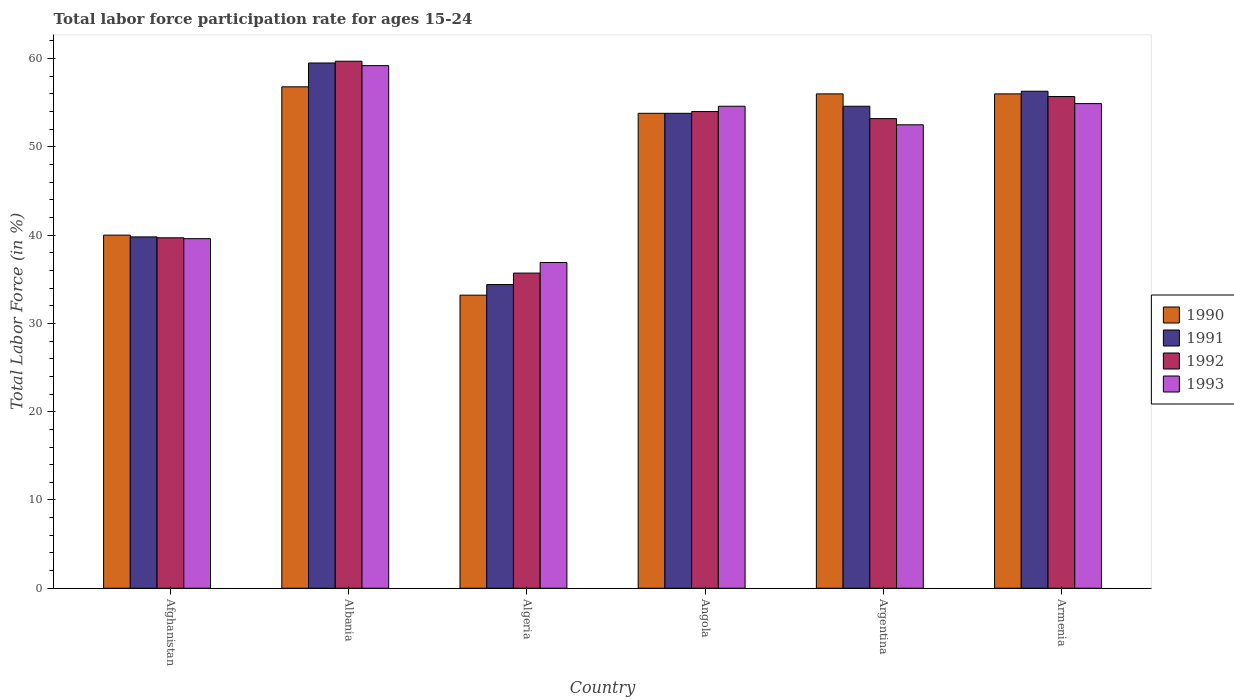How many different coloured bars are there?
Your answer should be very brief. 4. How many bars are there on the 6th tick from the right?
Provide a succinct answer. 4. In how many cases, is the number of bars for a given country not equal to the number of legend labels?
Your answer should be very brief. 0. Across all countries, what is the maximum labor force participation rate in 1990?
Ensure brevity in your answer.  56.8. Across all countries, what is the minimum labor force participation rate in 1991?
Make the answer very short. 34.4. In which country was the labor force participation rate in 1992 maximum?
Make the answer very short. Albania. In which country was the labor force participation rate in 1993 minimum?
Your answer should be compact. Algeria. What is the total labor force participation rate in 1992 in the graph?
Your answer should be very brief. 298. What is the difference between the labor force participation rate in 1993 in Albania and that in Angola?
Your answer should be compact. 4.6. What is the difference between the labor force participation rate in 1990 in Armenia and the labor force participation rate in 1993 in Angola?
Give a very brief answer. 1.4. What is the average labor force participation rate in 1990 per country?
Provide a succinct answer. 49.3. What is the difference between the labor force participation rate of/in 1991 and labor force participation rate of/in 1993 in Angola?
Offer a very short reply. -0.8. What is the ratio of the labor force participation rate in 1990 in Albania to that in Algeria?
Make the answer very short. 1.71. Is the labor force participation rate in 1992 in Afghanistan less than that in Armenia?
Your response must be concise. Yes. Is the difference between the labor force participation rate in 1991 in Albania and Angola greater than the difference between the labor force participation rate in 1993 in Albania and Angola?
Your answer should be very brief. Yes. What is the difference between the highest and the second highest labor force participation rate in 1993?
Offer a terse response. -4.6. What is the difference between the highest and the lowest labor force participation rate in 1990?
Your response must be concise. 23.6. Is it the case that in every country, the sum of the labor force participation rate in 1993 and labor force participation rate in 1990 is greater than the sum of labor force participation rate in 1992 and labor force participation rate in 1991?
Make the answer very short. No. What does the 3rd bar from the right in Albania represents?
Offer a very short reply. 1991. Are the values on the major ticks of Y-axis written in scientific E-notation?
Offer a very short reply. No. Does the graph contain grids?
Keep it short and to the point. No. Where does the legend appear in the graph?
Keep it short and to the point. Center right. How many legend labels are there?
Provide a short and direct response. 4. What is the title of the graph?
Your response must be concise. Total labor force participation rate for ages 15-24. What is the Total Labor Force (in %) of 1990 in Afghanistan?
Your response must be concise. 40. What is the Total Labor Force (in %) of 1991 in Afghanistan?
Your answer should be compact. 39.8. What is the Total Labor Force (in %) in 1992 in Afghanistan?
Keep it short and to the point. 39.7. What is the Total Labor Force (in %) of 1993 in Afghanistan?
Provide a succinct answer. 39.6. What is the Total Labor Force (in %) of 1990 in Albania?
Your answer should be very brief. 56.8. What is the Total Labor Force (in %) in 1991 in Albania?
Offer a terse response. 59.5. What is the Total Labor Force (in %) of 1992 in Albania?
Your answer should be very brief. 59.7. What is the Total Labor Force (in %) of 1993 in Albania?
Keep it short and to the point. 59.2. What is the Total Labor Force (in %) of 1990 in Algeria?
Keep it short and to the point. 33.2. What is the Total Labor Force (in %) in 1991 in Algeria?
Offer a very short reply. 34.4. What is the Total Labor Force (in %) of 1992 in Algeria?
Keep it short and to the point. 35.7. What is the Total Labor Force (in %) in 1993 in Algeria?
Keep it short and to the point. 36.9. What is the Total Labor Force (in %) of 1990 in Angola?
Offer a very short reply. 53.8. What is the Total Labor Force (in %) in 1991 in Angola?
Provide a succinct answer. 53.8. What is the Total Labor Force (in %) of 1993 in Angola?
Make the answer very short. 54.6. What is the Total Labor Force (in %) in 1990 in Argentina?
Make the answer very short. 56. What is the Total Labor Force (in %) of 1991 in Argentina?
Your response must be concise. 54.6. What is the Total Labor Force (in %) in 1992 in Argentina?
Offer a terse response. 53.2. What is the Total Labor Force (in %) in 1993 in Argentina?
Provide a short and direct response. 52.5. What is the Total Labor Force (in %) in 1991 in Armenia?
Provide a succinct answer. 56.3. What is the Total Labor Force (in %) of 1992 in Armenia?
Make the answer very short. 55.7. What is the Total Labor Force (in %) of 1993 in Armenia?
Your answer should be very brief. 54.9. Across all countries, what is the maximum Total Labor Force (in %) in 1990?
Your answer should be compact. 56.8. Across all countries, what is the maximum Total Labor Force (in %) in 1991?
Your response must be concise. 59.5. Across all countries, what is the maximum Total Labor Force (in %) of 1992?
Your response must be concise. 59.7. Across all countries, what is the maximum Total Labor Force (in %) in 1993?
Your answer should be compact. 59.2. Across all countries, what is the minimum Total Labor Force (in %) in 1990?
Offer a terse response. 33.2. Across all countries, what is the minimum Total Labor Force (in %) of 1991?
Provide a succinct answer. 34.4. Across all countries, what is the minimum Total Labor Force (in %) in 1992?
Your answer should be compact. 35.7. Across all countries, what is the minimum Total Labor Force (in %) of 1993?
Keep it short and to the point. 36.9. What is the total Total Labor Force (in %) in 1990 in the graph?
Your response must be concise. 295.8. What is the total Total Labor Force (in %) in 1991 in the graph?
Your answer should be compact. 298.4. What is the total Total Labor Force (in %) of 1992 in the graph?
Give a very brief answer. 298. What is the total Total Labor Force (in %) in 1993 in the graph?
Your response must be concise. 297.7. What is the difference between the Total Labor Force (in %) in 1990 in Afghanistan and that in Albania?
Keep it short and to the point. -16.8. What is the difference between the Total Labor Force (in %) in 1991 in Afghanistan and that in Albania?
Your response must be concise. -19.7. What is the difference between the Total Labor Force (in %) in 1993 in Afghanistan and that in Albania?
Your response must be concise. -19.6. What is the difference between the Total Labor Force (in %) in 1990 in Afghanistan and that in Algeria?
Provide a short and direct response. 6.8. What is the difference between the Total Labor Force (in %) in 1991 in Afghanistan and that in Algeria?
Give a very brief answer. 5.4. What is the difference between the Total Labor Force (in %) in 1992 in Afghanistan and that in Algeria?
Give a very brief answer. 4. What is the difference between the Total Labor Force (in %) in 1993 in Afghanistan and that in Algeria?
Keep it short and to the point. 2.7. What is the difference between the Total Labor Force (in %) in 1990 in Afghanistan and that in Angola?
Make the answer very short. -13.8. What is the difference between the Total Labor Force (in %) in 1992 in Afghanistan and that in Angola?
Offer a very short reply. -14.3. What is the difference between the Total Labor Force (in %) in 1993 in Afghanistan and that in Angola?
Your answer should be compact. -15. What is the difference between the Total Labor Force (in %) in 1991 in Afghanistan and that in Argentina?
Offer a very short reply. -14.8. What is the difference between the Total Labor Force (in %) of 1993 in Afghanistan and that in Argentina?
Your response must be concise. -12.9. What is the difference between the Total Labor Force (in %) in 1990 in Afghanistan and that in Armenia?
Your answer should be compact. -16. What is the difference between the Total Labor Force (in %) of 1991 in Afghanistan and that in Armenia?
Your answer should be very brief. -16.5. What is the difference between the Total Labor Force (in %) of 1993 in Afghanistan and that in Armenia?
Ensure brevity in your answer.  -15.3. What is the difference between the Total Labor Force (in %) of 1990 in Albania and that in Algeria?
Give a very brief answer. 23.6. What is the difference between the Total Labor Force (in %) in 1991 in Albania and that in Algeria?
Your answer should be very brief. 25.1. What is the difference between the Total Labor Force (in %) in 1992 in Albania and that in Algeria?
Give a very brief answer. 24. What is the difference between the Total Labor Force (in %) in 1993 in Albania and that in Algeria?
Keep it short and to the point. 22.3. What is the difference between the Total Labor Force (in %) in 1990 in Albania and that in Angola?
Ensure brevity in your answer.  3. What is the difference between the Total Labor Force (in %) in 1993 in Albania and that in Angola?
Your answer should be compact. 4.6. What is the difference between the Total Labor Force (in %) of 1991 in Albania and that in Argentina?
Your answer should be compact. 4.9. What is the difference between the Total Labor Force (in %) of 1992 in Albania and that in Argentina?
Offer a very short reply. 6.5. What is the difference between the Total Labor Force (in %) of 1993 in Albania and that in Armenia?
Make the answer very short. 4.3. What is the difference between the Total Labor Force (in %) of 1990 in Algeria and that in Angola?
Give a very brief answer. -20.6. What is the difference between the Total Labor Force (in %) in 1991 in Algeria and that in Angola?
Offer a very short reply. -19.4. What is the difference between the Total Labor Force (in %) of 1992 in Algeria and that in Angola?
Ensure brevity in your answer.  -18.3. What is the difference between the Total Labor Force (in %) of 1993 in Algeria and that in Angola?
Give a very brief answer. -17.7. What is the difference between the Total Labor Force (in %) of 1990 in Algeria and that in Argentina?
Offer a very short reply. -22.8. What is the difference between the Total Labor Force (in %) of 1991 in Algeria and that in Argentina?
Your answer should be very brief. -20.2. What is the difference between the Total Labor Force (in %) of 1992 in Algeria and that in Argentina?
Ensure brevity in your answer.  -17.5. What is the difference between the Total Labor Force (in %) of 1993 in Algeria and that in Argentina?
Ensure brevity in your answer.  -15.6. What is the difference between the Total Labor Force (in %) of 1990 in Algeria and that in Armenia?
Make the answer very short. -22.8. What is the difference between the Total Labor Force (in %) in 1991 in Algeria and that in Armenia?
Offer a terse response. -21.9. What is the difference between the Total Labor Force (in %) of 1992 in Algeria and that in Armenia?
Your response must be concise. -20. What is the difference between the Total Labor Force (in %) of 1992 in Angola and that in Argentina?
Your answer should be very brief. 0.8. What is the difference between the Total Labor Force (in %) of 1991 in Angola and that in Armenia?
Ensure brevity in your answer.  -2.5. What is the difference between the Total Labor Force (in %) in 1992 in Angola and that in Armenia?
Your answer should be very brief. -1.7. What is the difference between the Total Labor Force (in %) of 1990 in Argentina and that in Armenia?
Provide a short and direct response. 0. What is the difference between the Total Labor Force (in %) of 1992 in Argentina and that in Armenia?
Give a very brief answer. -2.5. What is the difference between the Total Labor Force (in %) in 1990 in Afghanistan and the Total Labor Force (in %) in 1991 in Albania?
Your answer should be compact. -19.5. What is the difference between the Total Labor Force (in %) in 1990 in Afghanistan and the Total Labor Force (in %) in 1992 in Albania?
Your response must be concise. -19.7. What is the difference between the Total Labor Force (in %) of 1990 in Afghanistan and the Total Labor Force (in %) of 1993 in Albania?
Ensure brevity in your answer.  -19.2. What is the difference between the Total Labor Force (in %) in 1991 in Afghanistan and the Total Labor Force (in %) in 1992 in Albania?
Provide a succinct answer. -19.9. What is the difference between the Total Labor Force (in %) in 1991 in Afghanistan and the Total Labor Force (in %) in 1993 in Albania?
Offer a terse response. -19.4. What is the difference between the Total Labor Force (in %) in 1992 in Afghanistan and the Total Labor Force (in %) in 1993 in Albania?
Ensure brevity in your answer.  -19.5. What is the difference between the Total Labor Force (in %) in 1990 in Afghanistan and the Total Labor Force (in %) in 1991 in Algeria?
Keep it short and to the point. 5.6. What is the difference between the Total Labor Force (in %) of 1990 in Afghanistan and the Total Labor Force (in %) of 1992 in Algeria?
Provide a short and direct response. 4.3. What is the difference between the Total Labor Force (in %) of 1990 in Afghanistan and the Total Labor Force (in %) of 1993 in Algeria?
Provide a short and direct response. 3.1. What is the difference between the Total Labor Force (in %) in 1991 in Afghanistan and the Total Labor Force (in %) in 1993 in Algeria?
Your response must be concise. 2.9. What is the difference between the Total Labor Force (in %) of 1990 in Afghanistan and the Total Labor Force (in %) of 1991 in Angola?
Your response must be concise. -13.8. What is the difference between the Total Labor Force (in %) of 1990 in Afghanistan and the Total Labor Force (in %) of 1992 in Angola?
Your response must be concise. -14. What is the difference between the Total Labor Force (in %) of 1990 in Afghanistan and the Total Labor Force (in %) of 1993 in Angola?
Make the answer very short. -14.6. What is the difference between the Total Labor Force (in %) of 1991 in Afghanistan and the Total Labor Force (in %) of 1993 in Angola?
Your answer should be very brief. -14.8. What is the difference between the Total Labor Force (in %) in 1992 in Afghanistan and the Total Labor Force (in %) in 1993 in Angola?
Offer a terse response. -14.9. What is the difference between the Total Labor Force (in %) in 1990 in Afghanistan and the Total Labor Force (in %) in 1991 in Argentina?
Keep it short and to the point. -14.6. What is the difference between the Total Labor Force (in %) in 1990 in Afghanistan and the Total Labor Force (in %) in 1992 in Argentina?
Your answer should be very brief. -13.2. What is the difference between the Total Labor Force (in %) in 1990 in Afghanistan and the Total Labor Force (in %) in 1993 in Argentina?
Ensure brevity in your answer.  -12.5. What is the difference between the Total Labor Force (in %) of 1991 in Afghanistan and the Total Labor Force (in %) of 1992 in Argentina?
Keep it short and to the point. -13.4. What is the difference between the Total Labor Force (in %) in 1992 in Afghanistan and the Total Labor Force (in %) in 1993 in Argentina?
Offer a terse response. -12.8. What is the difference between the Total Labor Force (in %) in 1990 in Afghanistan and the Total Labor Force (in %) in 1991 in Armenia?
Provide a succinct answer. -16.3. What is the difference between the Total Labor Force (in %) of 1990 in Afghanistan and the Total Labor Force (in %) of 1992 in Armenia?
Provide a succinct answer. -15.7. What is the difference between the Total Labor Force (in %) of 1990 in Afghanistan and the Total Labor Force (in %) of 1993 in Armenia?
Provide a succinct answer. -14.9. What is the difference between the Total Labor Force (in %) of 1991 in Afghanistan and the Total Labor Force (in %) of 1992 in Armenia?
Your answer should be compact. -15.9. What is the difference between the Total Labor Force (in %) of 1991 in Afghanistan and the Total Labor Force (in %) of 1993 in Armenia?
Make the answer very short. -15.1. What is the difference between the Total Labor Force (in %) in 1992 in Afghanistan and the Total Labor Force (in %) in 1993 in Armenia?
Provide a succinct answer. -15.2. What is the difference between the Total Labor Force (in %) of 1990 in Albania and the Total Labor Force (in %) of 1991 in Algeria?
Keep it short and to the point. 22.4. What is the difference between the Total Labor Force (in %) of 1990 in Albania and the Total Labor Force (in %) of 1992 in Algeria?
Your response must be concise. 21.1. What is the difference between the Total Labor Force (in %) in 1990 in Albania and the Total Labor Force (in %) in 1993 in Algeria?
Offer a terse response. 19.9. What is the difference between the Total Labor Force (in %) of 1991 in Albania and the Total Labor Force (in %) of 1992 in Algeria?
Offer a terse response. 23.8. What is the difference between the Total Labor Force (in %) in 1991 in Albania and the Total Labor Force (in %) in 1993 in Algeria?
Provide a succinct answer. 22.6. What is the difference between the Total Labor Force (in %) of 1992 in Albania and the Total Labor Force (in %) of 1993 in Algeria?
Your response must be concise. 22.8. What is the difference between the Total Labor Force (in %) in 1990 in Albania and the Total Labor Force (in %) in 1991 in Angola?
Keep it short and to the point. 3. What is the difference between the Total Labor Force (in %) in 1990 in Albania and the Total Labor Force (in %) in 1992 in Angola?
Make the answer very short. 2.8. What is the difference between the Total Labor Force (in %) of 1991 in Albania and the Total Labor Force (in %) of 1992 in Angola?
Your response must be concise. 5.5. What is the difference between the Total Labor Force (in %) in 1992 in Albania and the Total Labor Force (in %) in 1993 in Angola?
Keep it short and to the point. 5.1. What is the difference between the Total Labor Force (in %) in 1990 in Albania and the Total Labor Force (in %) in 1992 in Argentina?
Give a very brief answer. 3.6. What is the difference between the Total Labor Force (in %) in 1990 in Albania and the Total Labor Force (in %) in 1993 in Argentina?
Ensure brevity in your answer.  4.3. What is the difference between the Total Labor Force (in %) of 1991 in Albania and the Total Labor Force (in %) of 1993 in Argentina?
Provide a short and direct response. 7. What is the difference between the Total Labor Force (in %) in 1990 in Albania and the Total Labor Force (in %) in 1991 in Armenia?
Ensure brevity in your answer.  0.5. What is the difference between the Total Labor Force (in %) of 1991 in Albania and the Total Labor Force (in %) of 1993 in Armenia?
Provide a short and direct response. 4.6. What is the difference between the Total Labor Force (in %) of 1990 in Algeria and the Total Labor Force (in %) of 1991 in Angola?
Ensure brevity in your answer.  -20.6. What is the difference between the Total Labor Force (in %) in 1990 in Algeria and the Total Labor Force (in %) in 1992 in Angola?
Your answer should be compact. -20.8. What is the difference between the Total Labor Force (in %) in 1990 in Algeria and the Total Labor Force (in %) in 1993 in Angola?
Ensure brevity in your answer.  -21.4. What is the difference between the Total Labor Force (in %) of 1991 in Algeria and the Total Labor Force (in %) of 1992 in Angola?
Offer a very short reply. -19.6. What is the difference between the Total Labor Force (in %) in 1991 in Algeria and the Total Labor Force (in %) in 1993 in Angola?
Give a very brief answer. -20.2. What is the difference between the Total Labor Force (in %) in 1992 in Algeria and the Total Labor Force (in %) in 1993 in Angola?
Ensure brevity in your answer.  -18.9. What is the difference between the Total Labor Force (in %) of 1990 in Algeria and the Total Labor Force (in %) of 1991 in Argentina?
Provide a short and direct response. -21.4. What is the difference between the Total Labor Force (in %) of 1990 in Algeria and the Total Labor Force (in %) of 1993 in Argentina?
Give a very brief answer. -19.3. What is the difference between the Total Labor Force (in %) of 1991 in Algeria and the Total Labor Force (in %) of 1992 in Argentina?
Provide a succinct answer. -18.8. What is the difference between the Total Labor Force (in %) of 1991 in Algeria and the Total Labor Force (in %) of 1993 in Argentina?
Ensure brevity in your answer.  -18.1. What is the difference between the Total Labor Force (in %) of 1992 in Algeria and the Total Labor Force (in %) of 1993 in Argentina?
Offer a very short reply. -16.8. What is the difference between the Total Labor Force (in %) of 1990 in Algeria and the Total Labor Force (in %) of 1991 in Armenia?
Give a very brief answer. -23.1. What is the difference between the Total Labor Force (in %) in 1990 in Algeria and the Total Labor Force (in %) in 1992 in Armenia?
Keep it short and to the point. -22.5. What is the difference between the Total Labor Force (in %) in 1990 in Algeria and the Total Labor Force (in %) in 1993 in Armenia?
Give a very brief answer. -21.7. What is the difference between the Total Labor Force (in %) in 1991 in Algeria and the Total Labor Force (in %) in 1992 in Armenia?
Provide a succinct answer. -21.3. What is the difference between the Total Labor Force (in %) of 1991 in Algeria and the Total Labor Force (in %) of 1993 in Armenia?
Provide a short and direct response. -20.5. What is the difference between the Total Labor Force (in %) in 1992 in Algeria and the Total Labor Force (in %) in 1993 in Armenia?
Provide a short and direct response. -19.2. What is the difference between the Total Labor Force (in %) in 1990 in Angola and the Total Labor Force (in %) in 1992 in Argentina?
Keep it short and to the point. 0.6. What is the difference between the Total Labor Force (in %) of 1991 in Angola and the Total Labor Force (in %) of 1992 in Argentina?
Your response must be concise. 0.6. What is the difference between the Total Labor Force (in %) in 1992 in Angola and the Total Labor Force (in %) in 1993 in Argentina?
Provide a succinct answer. 1.5. What is the difference between the Total Labor Force (in %) of 1990 in Angola and the Total Labor Force (in %) of 1991 in Armenia?
Offer a very short reply. -2.5. What is the difference between the Total Labor Force (in %) in 1991 in Angola and the Total Labor Force (in %) in 1992 in Armenia?
Give a very brief answer. -1.9. What is the difference between the Total Labor Force (in %) of 1991 in Angola and the Total Labor Force (in %) of 1993 in Armenia?
Offer a very short reply. -1.1. What is the difference between the Total Labor Force (in %) of 1990 in Argentina and the Total Labor Force (in %) of 1992 in Armenia?
Provide a short and direct response. 0.3. What is the difference between the Total Labor Force (in %) in 1990 in Argentina and the Total Labor Force (in %) in 1993 in Armenia?
Your answer should be compact. 1.1. What is the difference between the Total Labor Force (in %) in 1991 in Argentina and the Total Labor Force (in %) in 1993 in Armenia?
Offer a very short reply. -0.3. What is the difference between the Total Labor Force (in %) of 1992 in Argentina and the Total Labor Force (in %) of 1993 in Armenia?
Your response must be concise. -1.7. What is the average Total Labor Force (in %) of 1990 per country?
Offer a terse response. 49.3. What is the average Total Labor Force (in %) of 1991 per country?
Ensure brevity in your answer.  49.73. What is the average Total Labor Force (in %) of 1992 per country?
Provide a short and direct response. 49.67. What is the average Total Labor Force (in %) of 1993 per country?
Your response must be concise. 49.62. What is the difference between the Total Labor Force (in %) in 1990 and Total Labor Force (in %) in 1991 in Afghanistan?
Provide a short and direct response. 0.2. What is the difference between the Total Labor Force (in %) in 1990 and Total Labor Force (in %) in 1992 in Afghanistan?
Ensure brevity in your answer.  0.3. What is the difference between the Total Labor Force (in %) of 1990 and Total Labor Force (in %) of 1993 in Afghanistan?
Make the answer very short. 0.4. What is the difference between the Total Labor Force (in %) of 1991 and Total Labor Force (in %) of 1993 in Afghanistan?
Offer a terse response. 0.2. What is the difference between the Total Labor Force (in %) of 1990 and Total Labor Force (in %) of 1991 in Albania?
Your response must be concise. -2.7. What is the difference between the Total Labor Force (in %) of 1990 and Total Labor Force (in %) of 1993 in Albania?
Make the answer very short. -2.4. What is the difference between the Total Labor Force (in %) in 1991 and Total Labor Force (in %) in 1993 in Albania?
Your answer should be very brief. 0.3. What is the difference between the Total Labor Force (in %) in 1992 and Total Labor Force (in %) in 1993 in Albania?
Provide a succinct answer. 0.5. What is the difference between the Total Labor Force (in %) of 1990 and Total Labor Force (in %) of 1992 in Algeria?
Make the answer very short. -2.5. What is the difference between the Total Labor Force (in %) of 1990 and Total Labor Force (in %) of 1993 in Algeria?
Keep it short and to the point. -3.7. What is the difference between the Total Labor Force (in %) of 1991 and Total Labor Force (in %) of 1992 in Algeria?
Make the answer very short. -1.3. What is the difference between the Total Labor Force (in %) in 1990 and Total Labor Force (in %) in 1992 in Angola?
Offer a terse response. -0.2. What is the difference between the Total Labor Force (in %) in 1991 and Total Labor Force (in %) in 1992 in Angola?
Your response must be concise. -0.2. What is the difference between the Total Labor Force (in %) of 1992 and Total Labor Force (in %) of 1993 in Angola?
Your answer should be compact. -0.6. What is the difference between the Total Labor Force (in %) in 1990 and Total Labor Force (in %) in 1991 in Argentina?
Your response must be concise. 1.4. What is the difference between the Total Labor Force (in %) in 1991 and Total Labor Force (in %) in 1992 in Argentina?
Your answer should be compact. 1.4. What is the difference between the Total Labor Force (in %) in 1992 and Total Labor Force (in %) in 1993 in Argentina?
Your answer should be compact. 0.7. What is the difference between the Total Labor Force (in %) in 1990 and Total Labor Force (in %) in 1991 in Armenia?
Provide a short and direct response. -0.3. What is the difference between the Total Labor Force (in %) of 1991 and Total Labor Force (in %) of 1992 in Armenia?
Keep it short and to the point. 0.6. What is the difference between the Total Labor Force (in %) of 1992 and Total Labor Force (in %) of 1993 in Armenia?
Keep it short and to the point. 0.8. What is the ratio of the Total Labor Force (in %) of 1990 in Afghanistan to that in Albania?
Ensure brevity in your answer.  0.7. What is the ratio of the Total Labor Force (in %) in 1991 in Afghanistan to that in Albania?
Keep it short and to the point. 0.67. What is the ratio of the Total Labor Force (in %) in 1992 in Afghanistan to that in Albania?
Keep it short and to the point. 0.67. What is the ratio of the Total Labor Force (in %) of 1993 in Afghanistan to that in Albania?
Your response must be concise. 0.67. What is the ratio of the Total Labor Force (in %) of 1990 in Afghanistan to that in Algeria?
Ensure brevity in your answer.  1.2. What is the ratio of the Total Labor Force (in %) in 1991 in Afghanistan to that in Algeria?
Your response must be concise. 1.16. What is the ratio of the Total Labor Force (in %) of 1992 in Afghanistan to that in Algeria?
Your answer should be very brief. 1.11. What is the ratio of the Total Labor Force (in %) of 1993 in Afghanistan to that in Algeria?
Your answer should be very brief. 1.07. What is the ratio of the Total Labor Force (in %) of 1990 in Afghanistan to that in Angola?
Ensure brevity in your answer.  0.74. What is the ratio of the Total Labor Force (in %) of 1991 in Afghanistan to that in Angola?
Make the answer very short. 0.74. What is the ratio of the Total Labor Force (in %) in 1992 in Afghanistan to that in Angola?
Provide a short and direct response. 0.74. What is the ratio of the Total Labor Force (in %) in 1993 in Afghanistan to that in Angola?
Provide a short and direct response. 0.73. What is the ratio of the Total Labor Force (in %) in 1990 in Afghanistan to that in Argentina?
Your response must be concise. 0.71. What is the ratio of the Total Labor Force (in %) of 1991 in Afghanistan to that in Argentina?
Your response must be concise. 0.73. What is the ratio of the Total Labor Force (in %) in 1992 in Afghanistan to that in Argentina?
Provide a succinct answer. 0.75. What is the ratio of the Total Labor Force (in %) in 1993 in Afghanistan to that in Argentina?
Offer a terse response. 0.75. What is the ratio of the Total Labor Force (in %) of 1991 in Afghanistan to that in Armenia?
Provide a short and direct response. 0.71. What is the ratio of the Total Labor Force (in %) in 1992 in Afghanistan to that in Armenia?
Provide a short and direct response. 0.71. What is the ratio of the Total Labor Force (in %) of 1993 in Afghanistan to that in Armenia?
Your response must be concise. 0.72. What is the ratio of the Total Labor Force (in %) in 1990 in Albania to that in Algeria?
Provide a succinct answer. 1.71. What is the ratio of the Total Labor Force (in %) of 1991 in Albania to that in Algeria?
Keep it short and to the point. 1.73. What is the ratio of the Total Labor Force (in %) in 1992 in Albania to that in Algeria?
Offer a terse response. 1.67. What is the ratio of the Total Labor Force (in %) of 1993 in Albania to that in Algeria?
Keep it short and to the point. 1.6. What is the ratio of the Total Labor Force (in %) of 1990 in Albania to that in Angola?
Provide a succinct answer. 1.06. What is the ratio of the Total Labor Force (in %) of 1991 in Albania to that in Angola?
Offer a very short reply. 1.11. What is the ratio of the Total Labor Force (in %) of 1992 in Albania to that in Angola?
Keep it short and to the point. 1.11. What is the ratio of the Total Labor Force (in %) of 1993 in Albania to that in Angola?
Your answer should be compact. 1.08. What is the ratio of the Total Labor Force (in %) of 1990 in Albania to that in Argentina?
Ensure brevity in your answer.  1.01. What is the ratio of the Total Labor Force (in %) of 1991 in Albania to that in Argentina?
Offer a terse response. 1.09. What is the ratio of the Total Labor Force (in %) in 1992 in Albania to that in Argentina?
Ensure brevity in your answer.  1.12. What is the ratio of the Total Labor Force (in %) of 1993 in Albania to that in Argentina?
Offer a very short reply. 1.13. What is the ratio of the Total Labor Force (in %) in 1990 in Albania to that in Armenia?
Offer a terse response. 1.01. What is the ratio of the Total Labor Force (in %) of 1991 in Albania to that in Armenia?
Your answer should be compact. 1.06. What is the ratio of the Total Labor Force (in %) in 1992 in Albania to that in Armenia?
Give a very brief answer. 1.07. What is the ratio of the Total Labor Force (in %) of 1993 in Albania to that in Armenia?
Make the answer very short. 1.08. What is the ratio of the Total Labor Force (in %) in 1990 in Algeria to that in Angola?
Offer a very short reply. 0.62. What is the ratio of the Total Labor Force (in %) in 1991 in Algeria to that in Angola?
Offer a very short reply. 0.64. What is the ratio of the Total Labor Force (in %) of 1992 in Algeria to that in Angola?
Your response must be concise. 0.66. What is the ratio of the Total Labor Force (in %) in 1993 in Algeria to that in Angola?
Provide a short and direct response. 0.68. What is the ratio of the Total Labor Force (in %) of 1990 in Algeria to that in Argentina?
Your response must be concise. 0.59. What is the ratio of the Total Labor Force (in %) in 1991 in Algeria to that in Argentina?
Your response must be concise. 0.63. What is the ratio of the Total Labor Force (in %) in 1992 in Algeria to that in Argentina?
Provide a succinct answer. 0.67. What is the ratio of the Total Labor Force (in %) in 1993 in Algeria to that in Argentina?
Offer a very short reply. 0.7. What is the ratio of the Total Labor Force (in %) in 1990 in Algeria to that in Armenia?
Your answer should be very brief. 0.59. What is the ratio of the Total Labor Force (in %) of 1991 in Algeria to that in Armenia?
Offer a very short reply. 0.61. What is the ratio of the Total Labor Force (in %) in 1992 in Algeria to that in Armenia?
Your answer should be compact. 0.64. What is the ratio of the Total Labor Force (in %) in 1993 in Algeria to that in Armenia?
Keep it short and to the point. 0.67. What is the ratio of the Total Labor Force (in %) in 1990 in Angola to that in Argentina?
Your answer should be compact. 0.96. What is the ratio of the Total Labor Force (in %) of 1991 in Angola to that in Argentina?
Offer a very short reply. 0.99. What is the ratio of the Total Labor Force (in %) of 1993 in Angola to that in Argentina?
Offer a terse response. 1.04. What is the ratio of the Total Labor Force (in %) in 1990 in Angola to that in Armenia?
Offer a very short reply. 0.96. What is the ratio of the Total Labor Force (in %) in 1991 in Angola to that in Armenia?
Provide a succinct answer. 0.96. What is the ratio of the Total Labor Force (in %) in 1992 in Angola to that in Armenia?
Your answer should be very brief. 0.97. What is the ratio of the Total Labor Force (in %) in 1993 in Angola to that in Armenia?
Provide a short and direct response. 0.99. What is the ratio of the Total Labor Force (in %) in 1990 in Argentina to that in Armenia?
Give a very brief answer. 1. What is the ratio of the Total Labor Force (in %) in 1991 in Argentina to that in Armenia?
Offer a very short reply. 0.97. What is the ratio of the Total Labor Force (in %) of 1992 in Argentina to that in Armenia?
Ensure brevity in your answer.  0.96. What is the ratio of the Total Labor Force (in %) of 1993 in Argentina to that in Armenia?
Give a very brief answer. 0.96. What is the difference between the highest and the second highest Total Labor Force (in %) in 1990?
Your response must be concise. 0.8. What is the difference between the highest and the second highest Total Labor Force (in %) in 1991?
Make the answer very short. 3.2. What is the difference between the highest and the lowest Total Labor Force (in %) of 1990?
Your answer should be very brief. 23.6. What is the difference between the highest and the lowest Total Labor Force (in %) in 1991?
Ensure brevity in your answer.  25.1. What is the difference between the highest and the lowest Total Labor Force (in %) in 1992?
Give a very brief answer. 24. What is the difference between the highest and the lowest Total Labor Force (in %) of 1993?
Your answer should be compact. 22.3. 